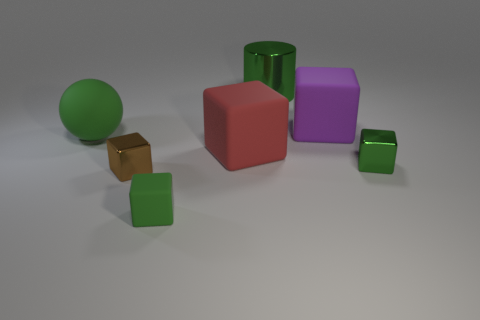Subtract all red blocks. How many blocks are left? 4 Subtract all purple cubes. How many cubes are left? 4 Subtract all blue cubes. Subtract all purple balls. How many cubes are left? 5 Add 1 large purple rubber cubes. How many objects exist? 8 Subtract all blocks. How many objects are left? 2 Add 2 small brown objects. How many small brown objects exist? 3 Subtract 0 blue cylinders. How many objects are left? 7 Subtract all large metallic objects. Subtract all green cylinders. How many objects are left? 5 Add 5 metallic blocks. How many metallic blocks are left? 7 